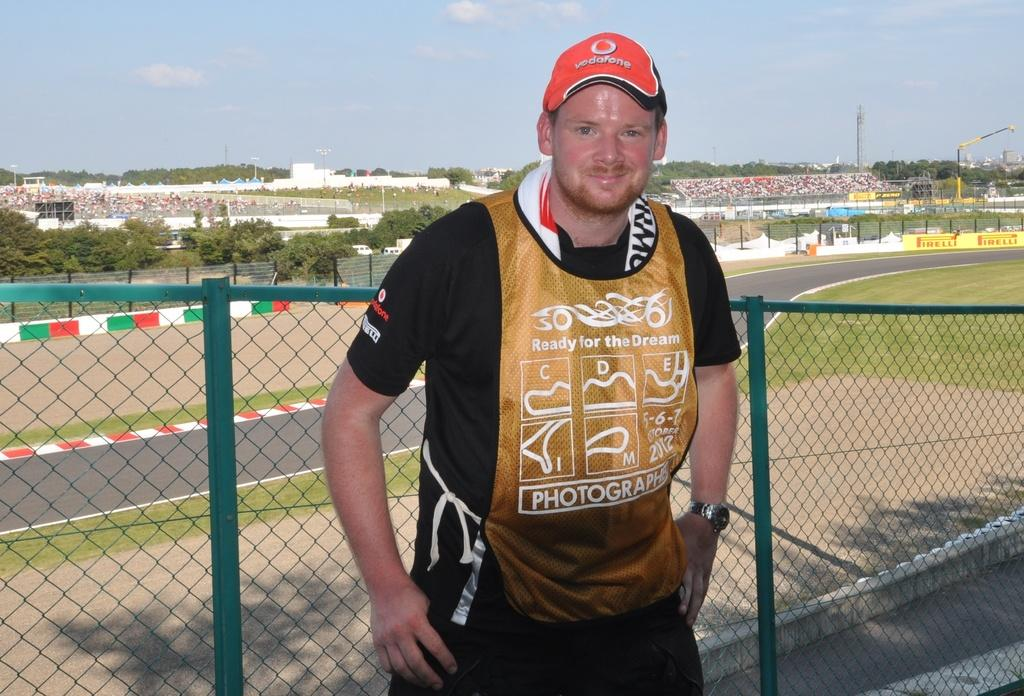Provide a one-sentence caption for the provided image. We can see a young fellow, wearing a red, photographer vest and a red, baseball cap. 